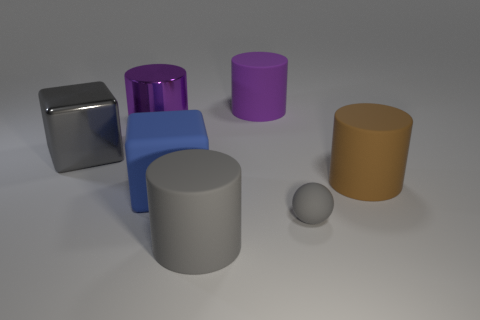Is the shape of the purple rubber thing the same as the big metallic thing that is right of the big gray block?
Your answer should be very brief. Yes. What number of blocks are small gray things or large gray things?
Keep it short and to the point. 1. The small rubber object is what color?
Your answer should be very brief. Gray. Is the number of gray cubes greater than the number of blue metallic blocks?
Give a very brief answer. Yes. What number of objects are either gray objects that are on the left side of the tiny sphere or gray balls?
Provide a succinct answer. 3. Are the large gray cylinder and the small gray sphere made of the same material?
Give a very brief answer. Yes. There is a brown rubber thing that is the same shape as the purple rubber object; what is its size?
Offer a very short reply. Large. Is the shape of the thing right of the small matte ball the same as the big gray thing behind the brown cylinder?
Your answer should be compact. No. There is a brown rubber object; does it have the same size as the cylinder in front of the small gray thing?
Offer a very short reply. Yes. How many other objects are there of the same material as the tiny gray thing?
Make the answer very short. 4. 